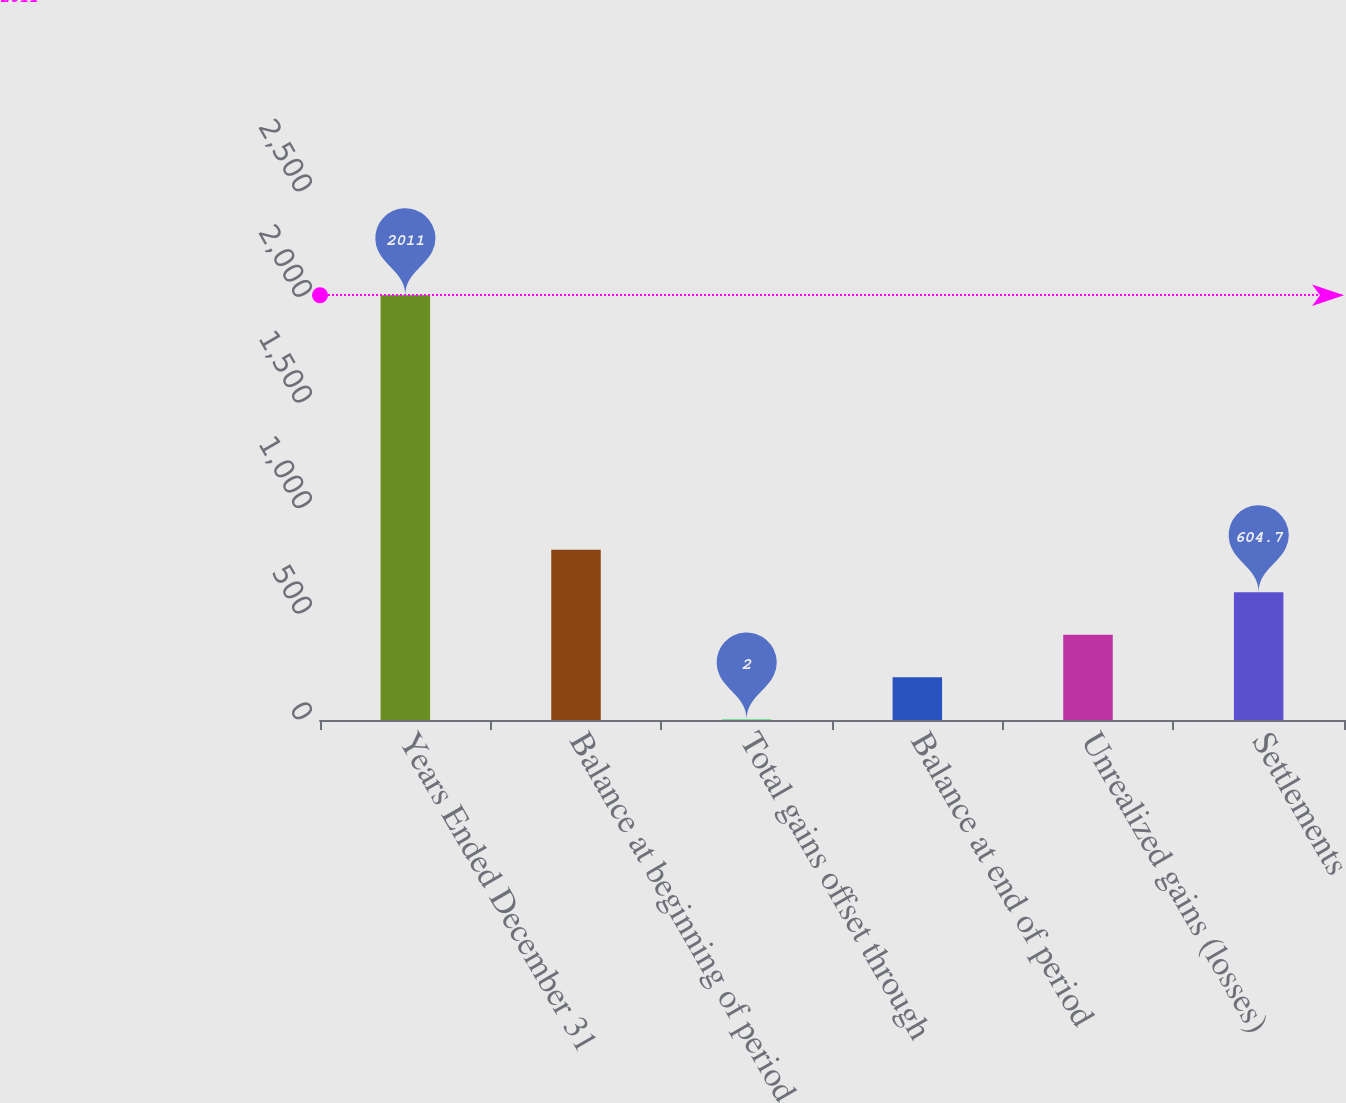<chart> <loc_0><loc_0><loc_500><loc_500><bar_chart><fcel>Years Ended December 31<fcel>Balance at beginning of period<fcel>Total gains offset through<fcel>Balance at end of period<fcel>Unrealized gains (losses)<fcel>Settlements<nl><fcel>2011<fcel>805.6<fcel>2<fcel>202.9<fcel>403.8<fcel>604.7<nl></chart> 